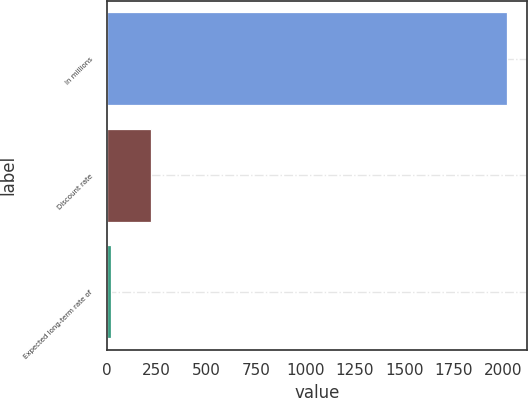<chart> <loc_0><loc_0><loc_500><loc_500><bar_chart><fcel>In millions<fcel>Discount rate<fcel>Expected long-term rate of<nl><fcel>2019<fcel>221.7<fcel>22<nl></chart> 